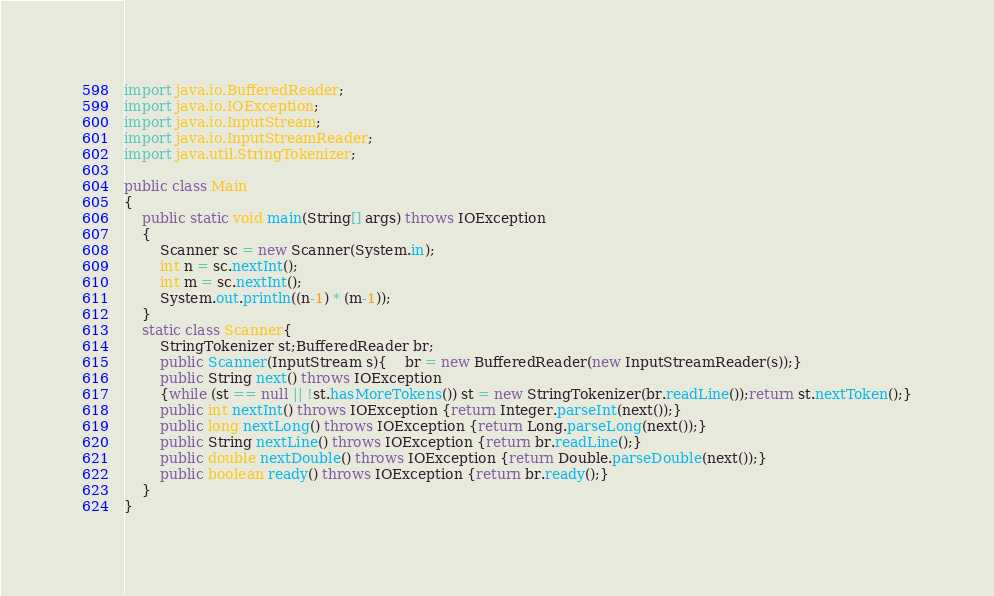<code> <loc_0><loc_0><loc_500><loc_500><_Java_>import java.io.BufferedReader;
import java.io.IOException;
import java.io.InputStream;
import java.io.InputStreamReader;
import java.util.StringTokenizer;

public class Main
{
	public static void main(String[] args) throws IOException
	{
		Scanner sc = new Scanner(System.in);
		int n = sc.nextInt();
		int m = sc.nextInt();
		System.out.println((n-1) * (m-1));
	}
	static class Scanner{
		StringTokenizer st;BufferedReader br;
		public Scanner(InputStream s){	br = new BufferedReader(new InputStreamReader(s));}
		public String next() throws IOException 
		{while (st == null || !st.hasMoreTokens()) st = new StringTokenizer(br.readLine());return st.nextToken();}
		public int nextInt() throws IOException {return Integer.parseInt(next());}
		public long nextLong() throws IOException {return Long.parseLong(next());}
		public String nextLine() throws IOException {return br.readLine();}
		public double nextDouble() throws IOException {return Double.parseDouble(next());}
		public boolean ready() throws IOException {return br.ready();}
	}
}
</code> 